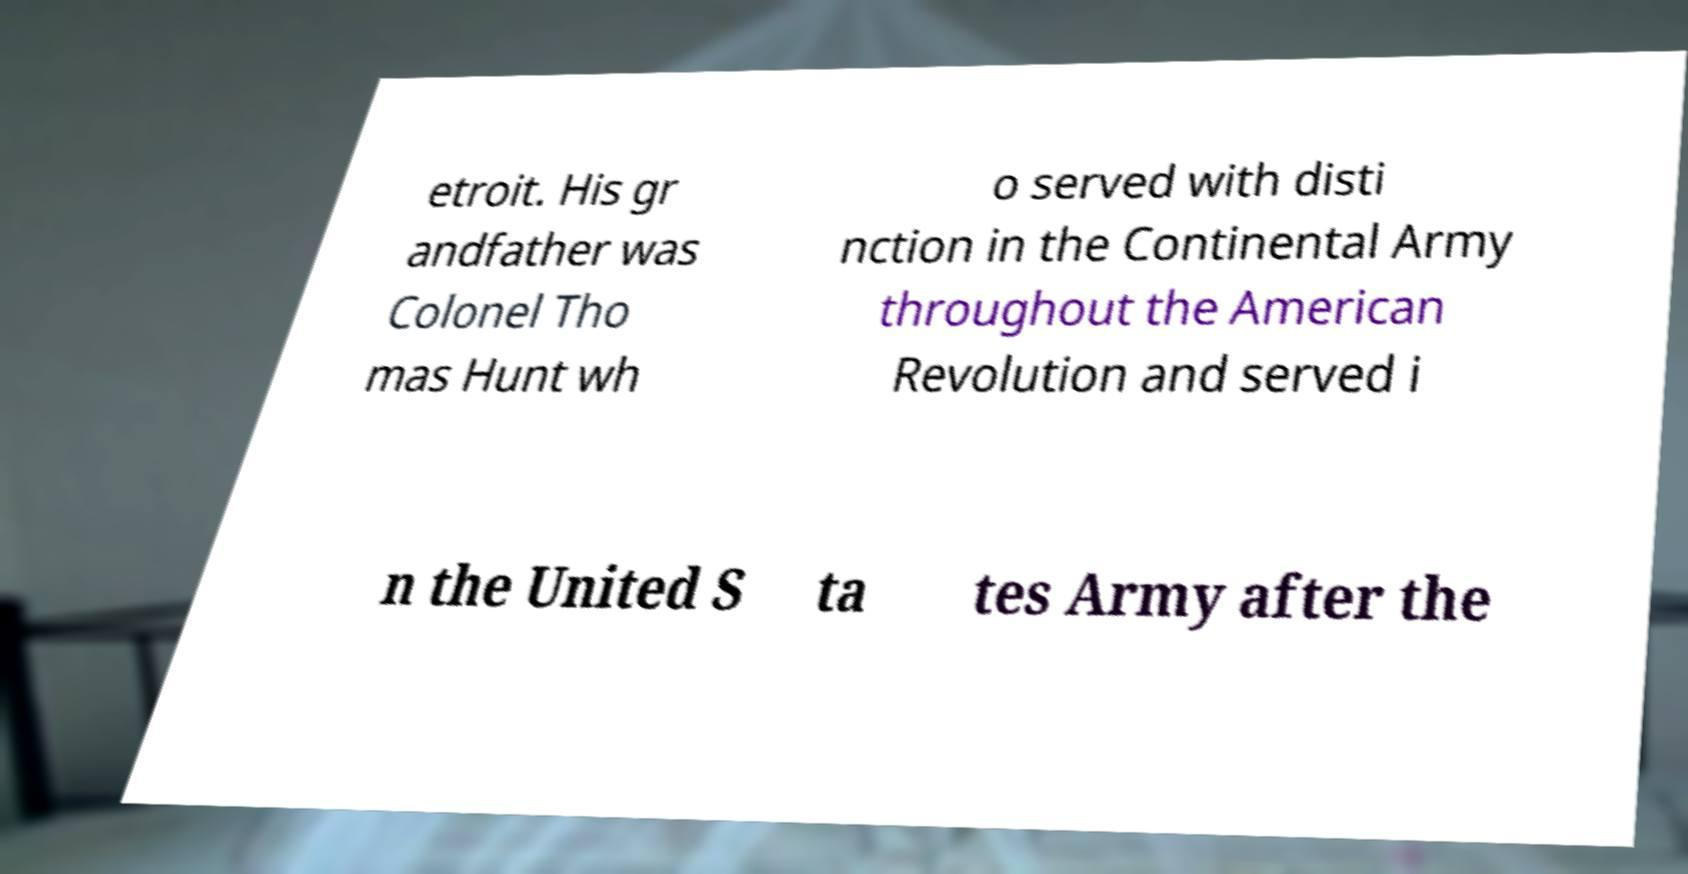Could you extract and type out the text from this image? etroit. His gr andfather was Colonel Tho mas Hunt wh o served with disti nction in the Continental Army throughout the American Revolution and served i n the United S ta tes Army after the 